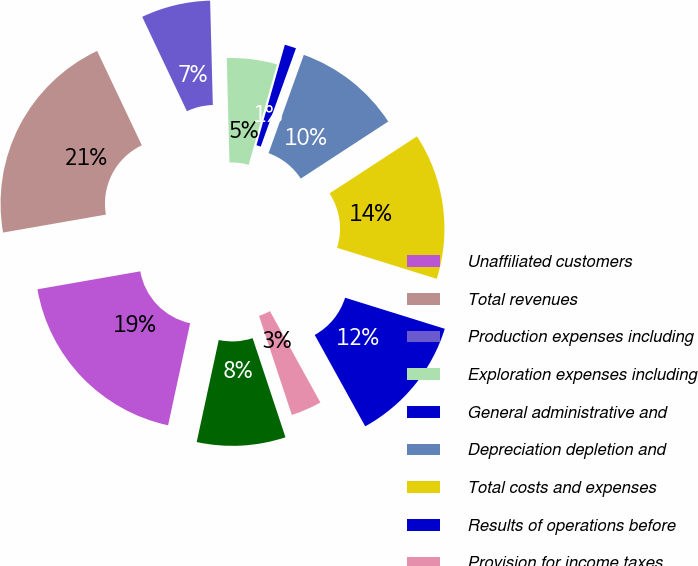Convert chart to OTSL. <chart><loc_0><loc_0><loc_500><loc_500><pie_chart><fcel>Unaffiliated customers<fcel>Total revenues<fcel>Production expenses including<fcel>Exploration expenses including<fcel>General administrative and<fcel>Depreciation depletion and<fcel>Total costs and expenses<fcel>Results of operations before<fcel>Provision for income taxes<fcel>Results of operations<nl><fcel>18.86%<fcel>20.71%<fcel>6.63%<fcel>4.79%<fcel>1.1%<fcel>10.32%<fcel>14.01%<fcel>12.16%<fcel>2.94%<fcel>8.48%<nl></chart> 